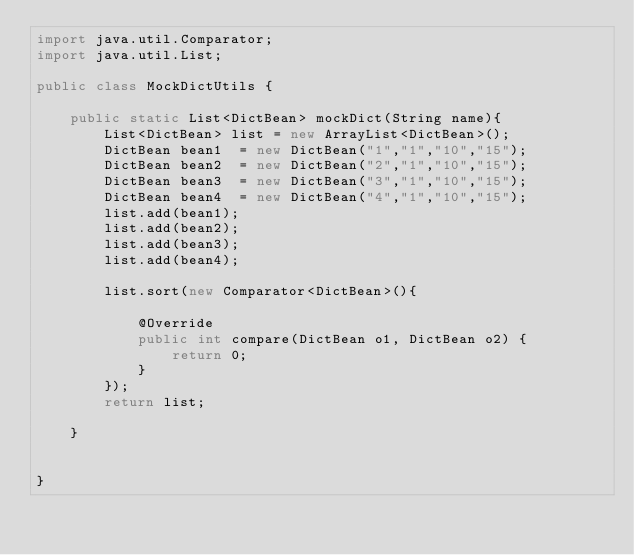Convert code to text. <code><loc_0><loc_0><loc_500><loc_500><_Java_>import java.util.Comparator;
import java.util.List;

public class MockDictUtils {

    public static List<DictBean> mockDict(String name){
        List<DictBean> list = new ArrayList<DictBean>();
        DictBean bean1  = new DictBean("1","1","10","15");
        DictBean bean2  = new DictBean("2","1","10","15");
        DictBean bean3  = new DictBean("3","1","10","15");
        DictBean bean4  = new DictBean("4","1","10","15");
        list.add(bean1);
        list.add(bean2);
        list.add(bean3);
        list.add(bean4);

        list.sort(new Comparator<DictBean>(){

            @Override
            public int compare(DictBean o1, DictBean o2) {
                return 0;
            }
        });
        return list;

    }


}
</code> 